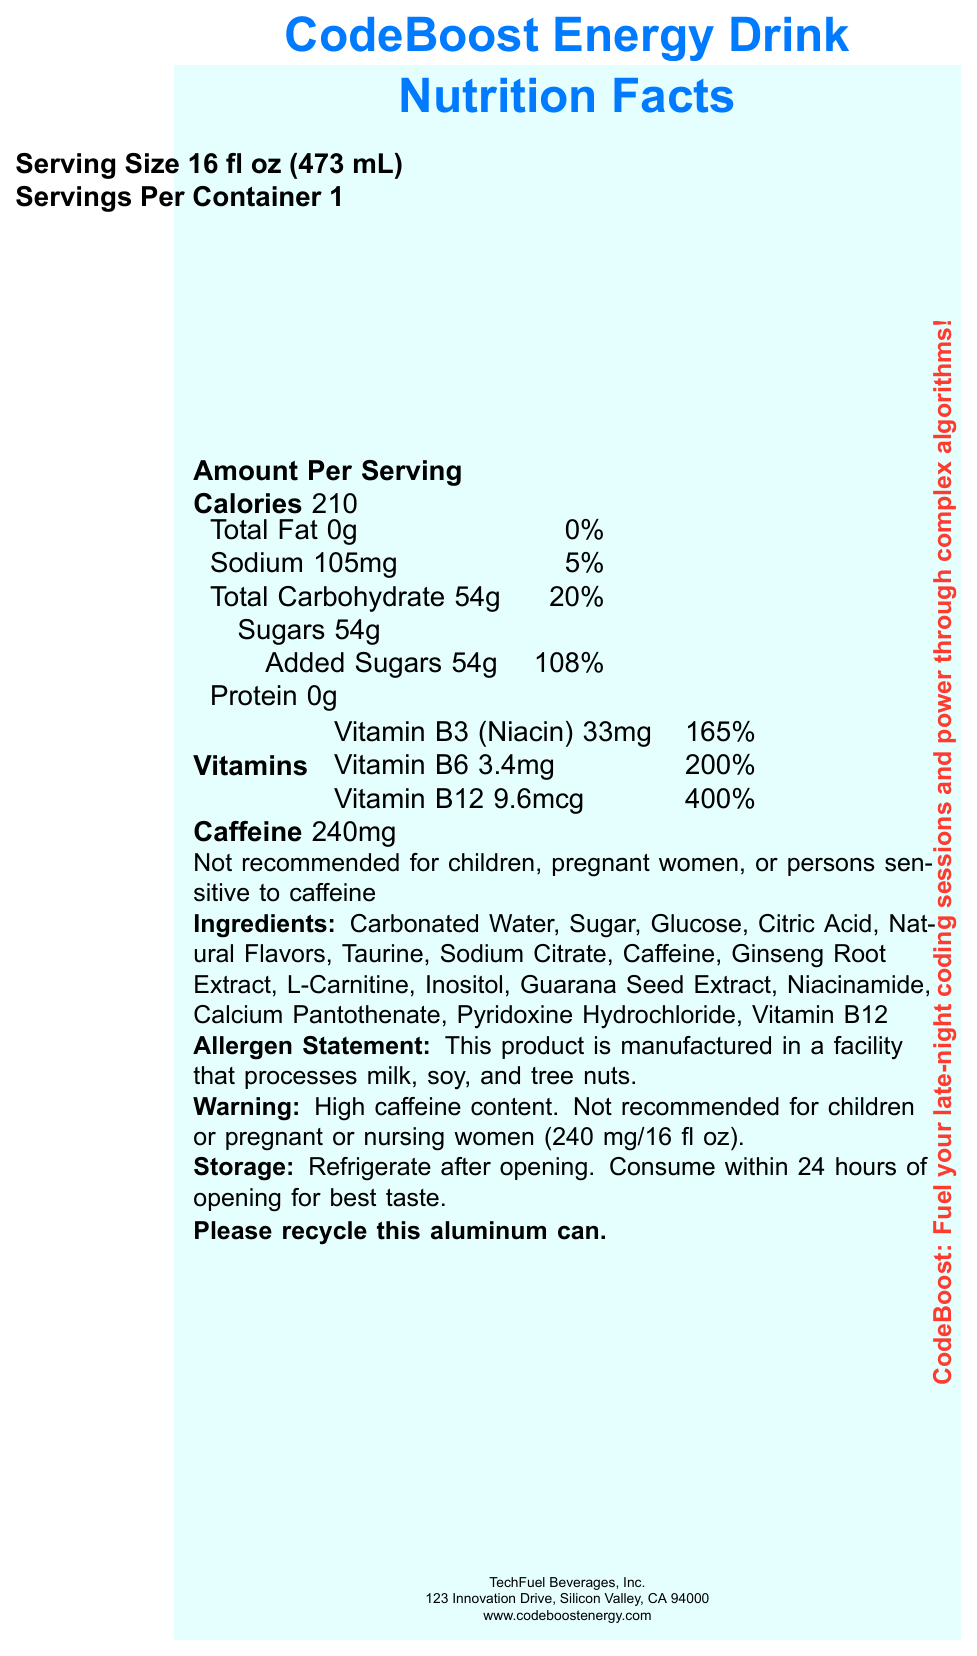what is the serving size? The serving size is explicitly mentioned at the top of the document under "Serving Size 16 fl oz (473 mL)".
Answer: 16 fl oz (473 mL) how many calories are in one serving of CodeBoost Energy Drink? The document states "Calories 210" under the "Amount Per Serving" section.
Answer: 210 what is the amount of added sugars per serving? The document specifies "Sugars 54g" and "Added Sugars 54g" under the "Total Carbohydrate" section.
Answer: 54g what is the caffeine content per serving? The caffeine content is listed as "Caffeine 240mg" in the document. There's also a warning mentioning the high caffeine content.
Answer: 240mg which vitamin has the highest daily value percentage in the drink? The document lists the daily value percentages for the vitamins, and Vitamin B12 has the highest with "400%".
Answer: Vitamin B12 what is the sodium content per serving? The document states "Sodium 105mg" under the "Amount Per Serving" section.
Answer: 105mg which of the following is not listed as an ingredient in the drink? A. Taurine B. Inositol C. Glucose D. Maltodextrin Maltodextrin is not listed among the ingredients in the document, while the other options are.
Answer: D. Maltodextrin what is the daily value percentage of Vitamin B3 (Niacin) per serving? A. 200% B. 165% C. 400% D. 108% The daily value percentage for Vitamin B3 (Niacin) is listed as "165%" in the document.
Answer: B. 165% is this product safe for children? The document explicitly states that the drink is "Not recommended for children" due to high caffeine content.
Answer: No summarize the main highlights of the document. The summary encapsulates the critical nutritional information, ingredient list, and warnings provided in the document.
Answer: CodeBoost Energy Drink provides high calories (210) per serving, contains significant caffeine (240mg) and B-vitamins with high daily value percentages, especially Vitamin B12 (400%). This drink is not recommended for children, pregnant women, or those sensitive to caffeine. It has a high sugar content and includes various ingredients like Taurine, Glucose, and natural flavors. who is the target audience for the CodeBoost Energy Drink? The document does not provide specific information on the target audience beyond warnings about who should avoid the product, such as children and pregnant women.
Answer: Cannot be determined 